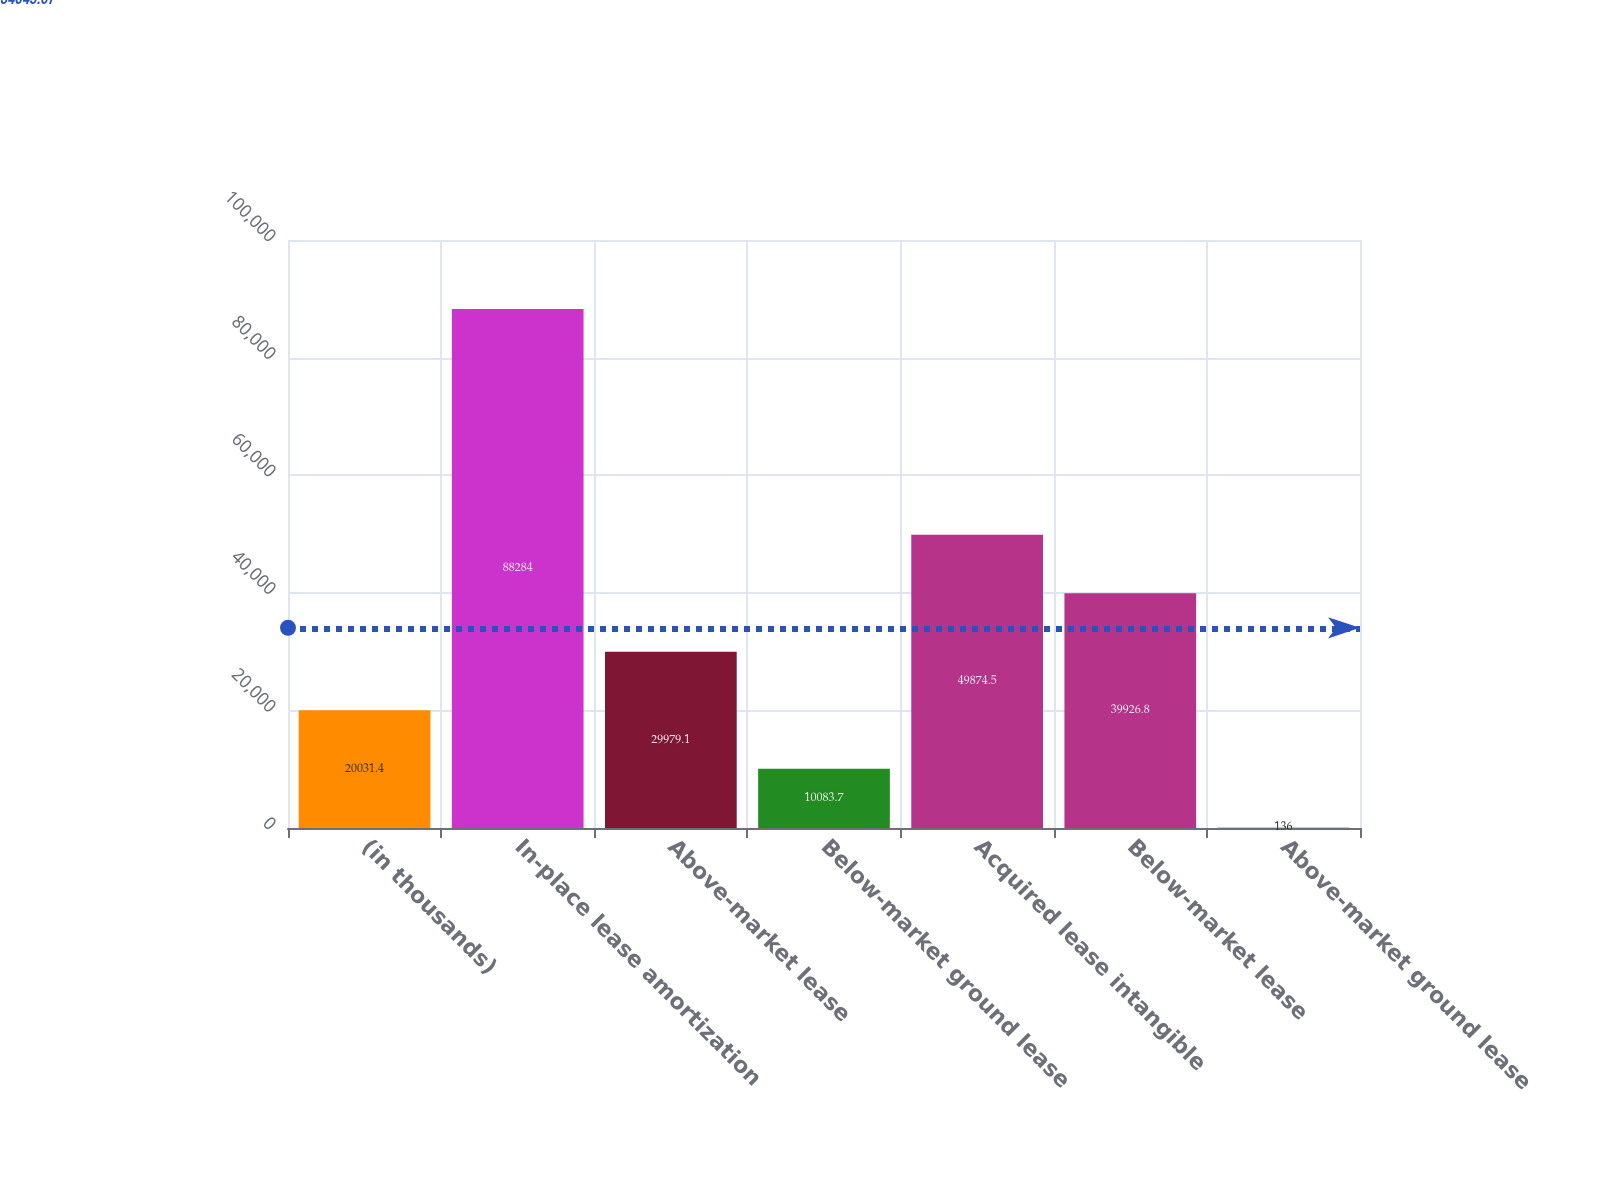Convert chart. <chart><loc_0><loc_0><loc_500><loc_500><bar_chart><fcel>(in thousands)<fcel>In-place lease amortization<fcel>Above-market lease<fcel>Below-market ground lease<fcel>Acquired lease intangible<fcel>Below-market lease<fcel>Above-market ground lease<nl><fcel>20031.4<fcel>88284<fcel>29979.1<fcel>10083.7<fcel>49874.5<fcel>39926.8<fcel>136<nl></chart> 